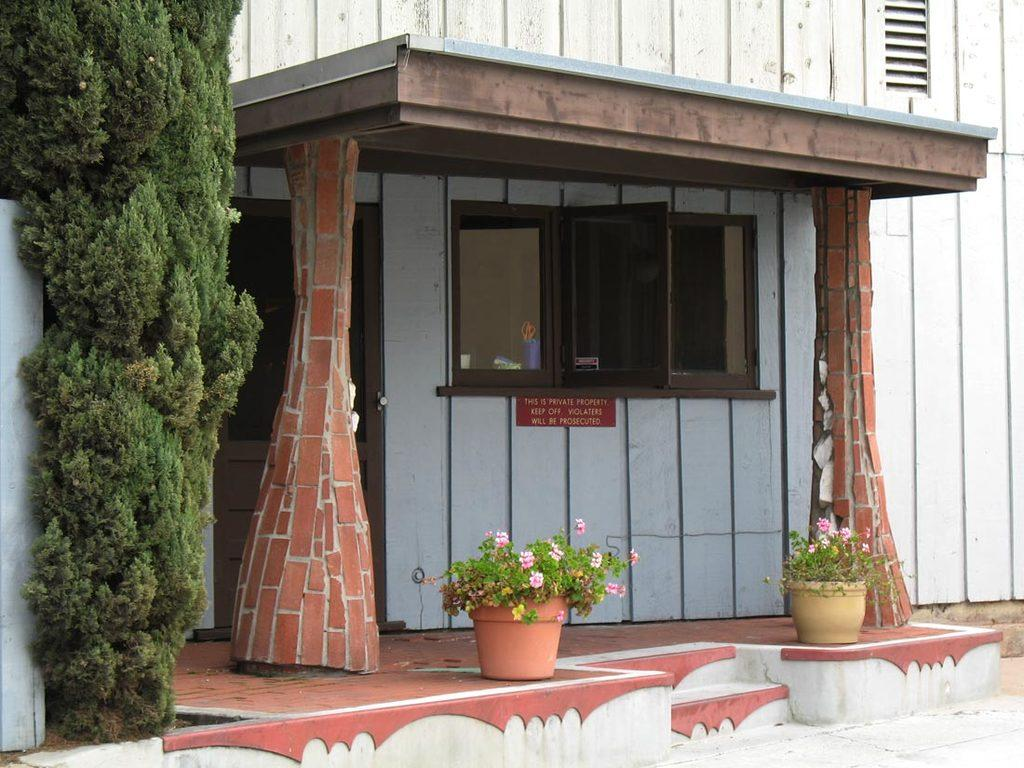What type of structure is visible in the image? There is a building in the image. What can be seen in the center of the image? There is an arch, plants, and windows in the center of the image. Where is the tree located in the image? The tree is on the left side of the image. What type of grape is being used as a cap for the writing in the image? There is no grape, cap, or writing present in the image. 